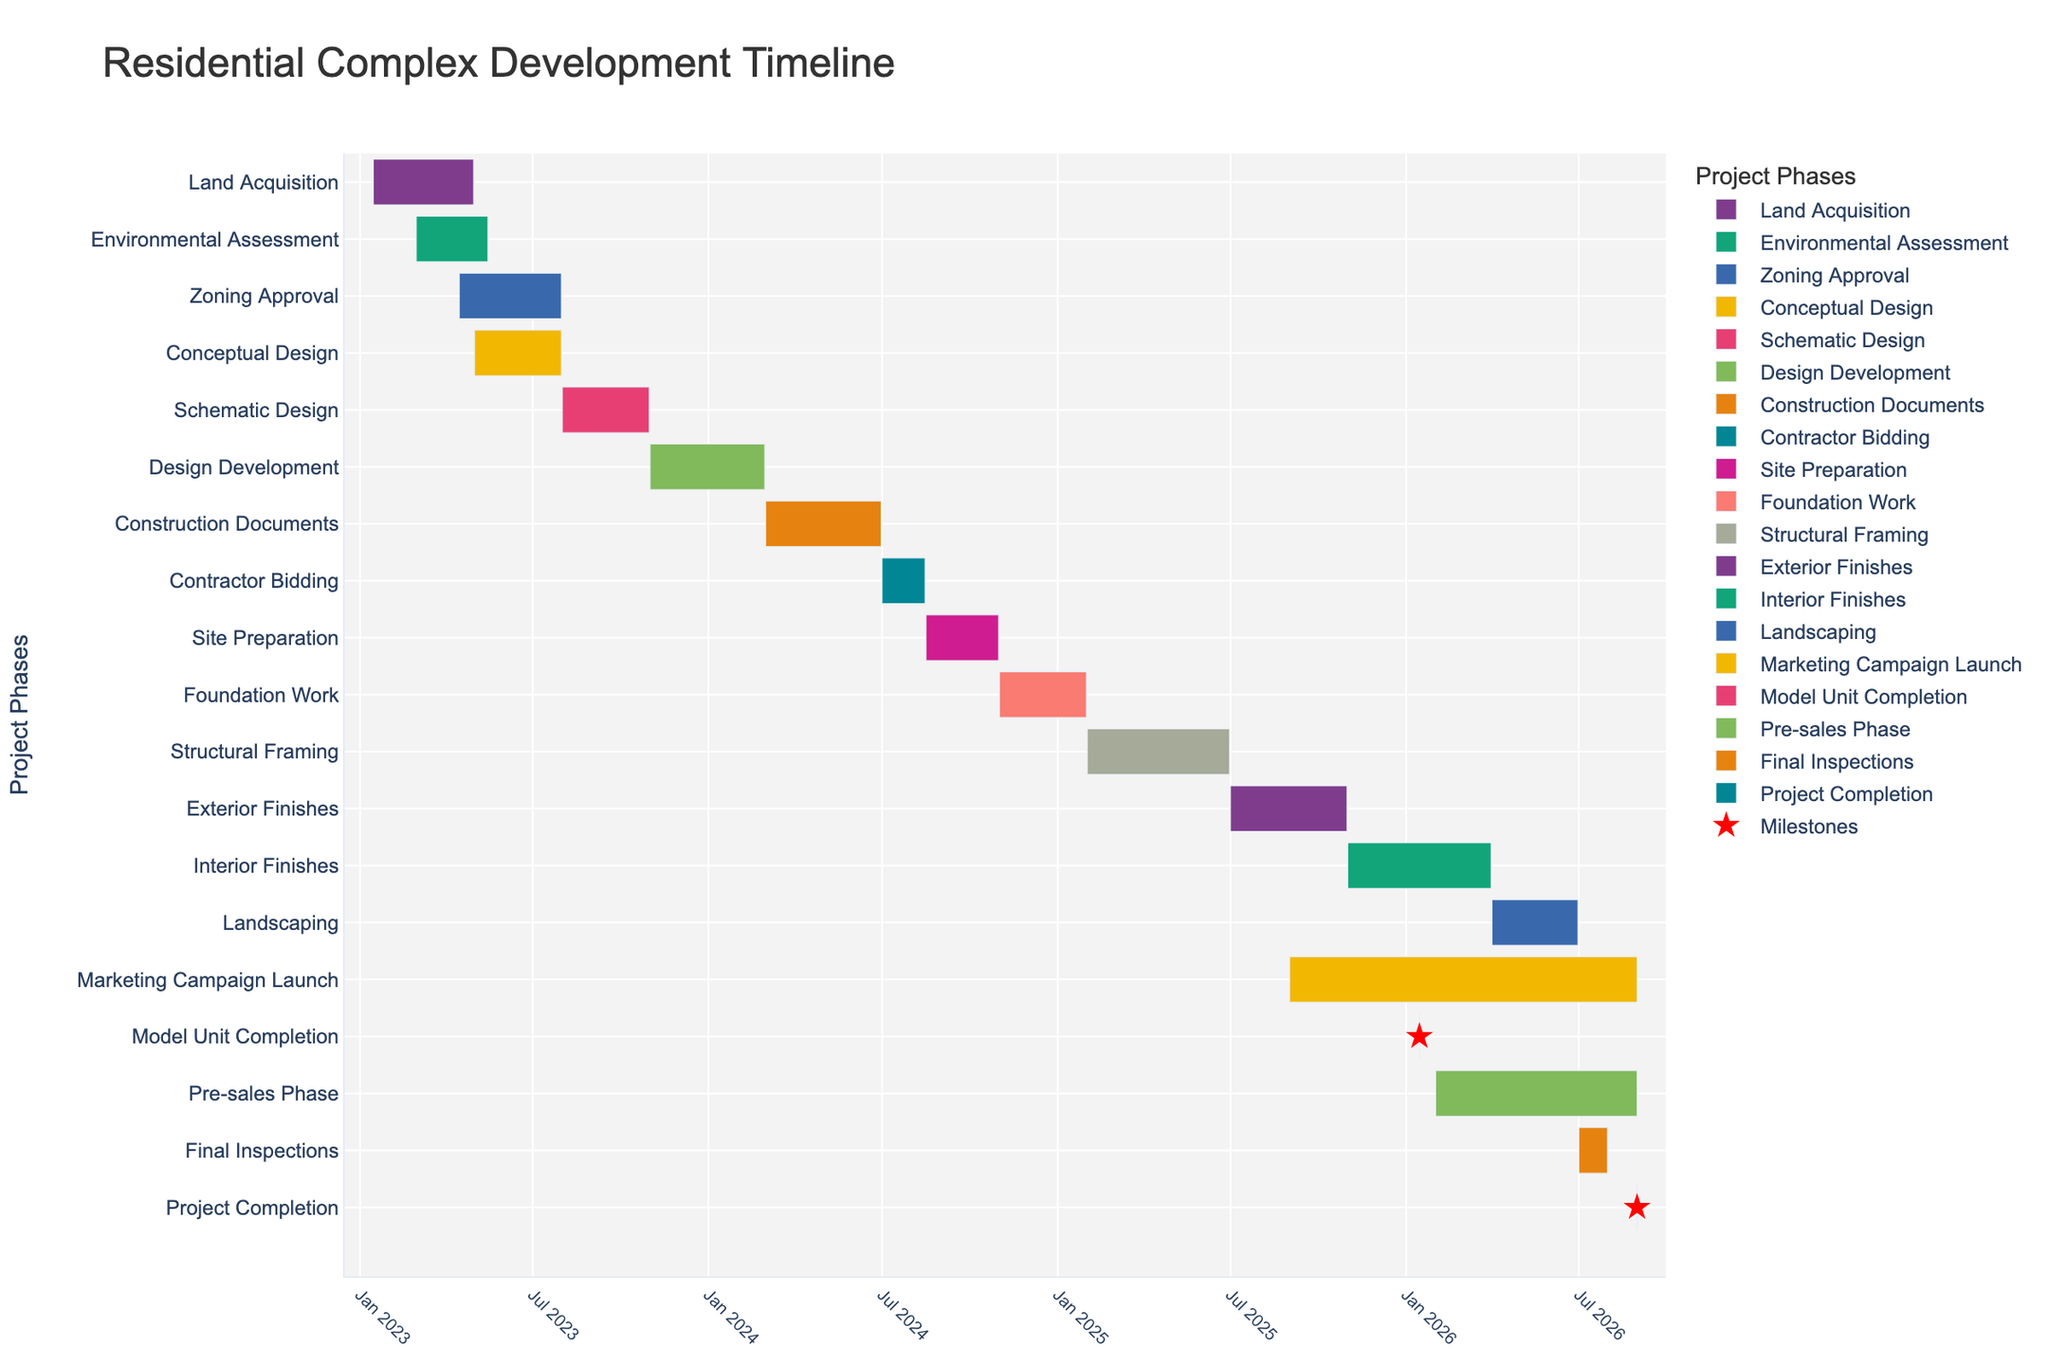When does the Environmental Assessment phase start and end? The Environmental Assessment phase starts on March 1, 2023, and ends on May 15, 2023. This information can be referenced by looking at the timeline for the Environmental Assessment on the y-axis.
Answer: March 1, 2023 - May 15, 2023 How long is the Construction Documents phase? The Gantt chart shows the Construction Documents phase starts on March 1, 2024, and ends on June 30, 2024. By calculating the duration, we find it lasts 4 months.
Answer: 4 months Which two phases overlap between April and May 2023? Observing the timeline, both the Environmental Assessment and Land Acquisition phases overlap in the months of April and May 2023.
Answer: Environmental Assessment and Land Acquisition What is the latest milestone depicted in the Gantt chart? The Gantt chart indicates that the latest milestone is the Project Completion, which occurs on August 31, 2026. This can be seen by finding the red star markers and identifying the furthest right point.
Answer: August 31, 2026 Which phase immediately follows the Schematic Design phase? The timeline shows that the Design Development phase immediately follows the Schematic Design phase. Schematic Design ends on October 31, 2023, and Design Development starts on November 1, 2023.
Answer: Design Development During which period does the Marketing Campaign Launch take place? The Marketing Campaign Launch starts on September 1, 2025, and goes until August 31, 2026. This can be determined by observing the horizontal bar labeled Marketing Campaign Launch.
Answer: September 1, 2025 - August 31, 2026 What is the total duration of the Conceptual Design phase? The Conceptual Design phase starts on May 1, 2023, and ends on July 31, 2023. Calculating the time span, the duration is 3 months.
Answer: 3 months Are there any phases that start and end on the same date? If so, name one. Observing the red star markers which indicate milestones, one phase that starts and ends on the same date is the Model Unit Completion occurring on January 15, 2026.
Answer: Model Unit Completion Which phase lasts the longest, and how long is that phase? By comparing the durations of the phases, the Interior Finishes phase lasts the longest, starting on November 1, 2025, and ending on March 31, 2026. This gives a duration of 5 months.
Answer: Interior Finishes, 5 months 